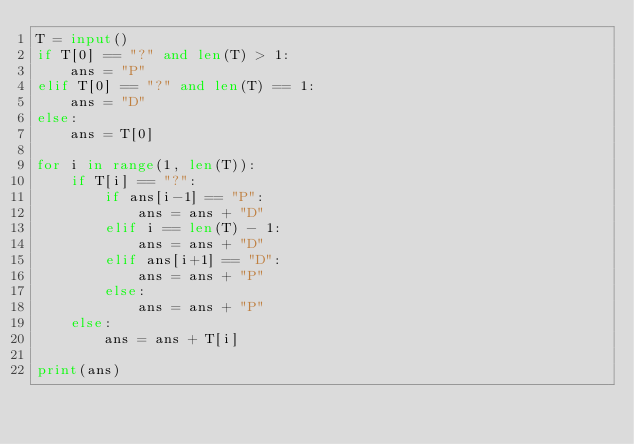<code> <loc_0><loc_0><loc_500><loc_500><_Python_>T = input()
if T[0] == "?" and len(T) > 1:
    ans = "P"
elif T[0] == "?" and len(T) == 1:
    ans = "D"
else:
    ans = T[0]

for i in range(1, len(T)):
    if T[i] == "?":
        if ans[i-1] == "P":
            ans = ans + "D"
        elif i == len(T) - 1:
            ans = ans + "D"
        elif ans[i+1] == "D":
            ans = ans + "P"
        else:
            ans = ans + "P"
    else:
        ans = ans + T[i]

print(ans)</code> 